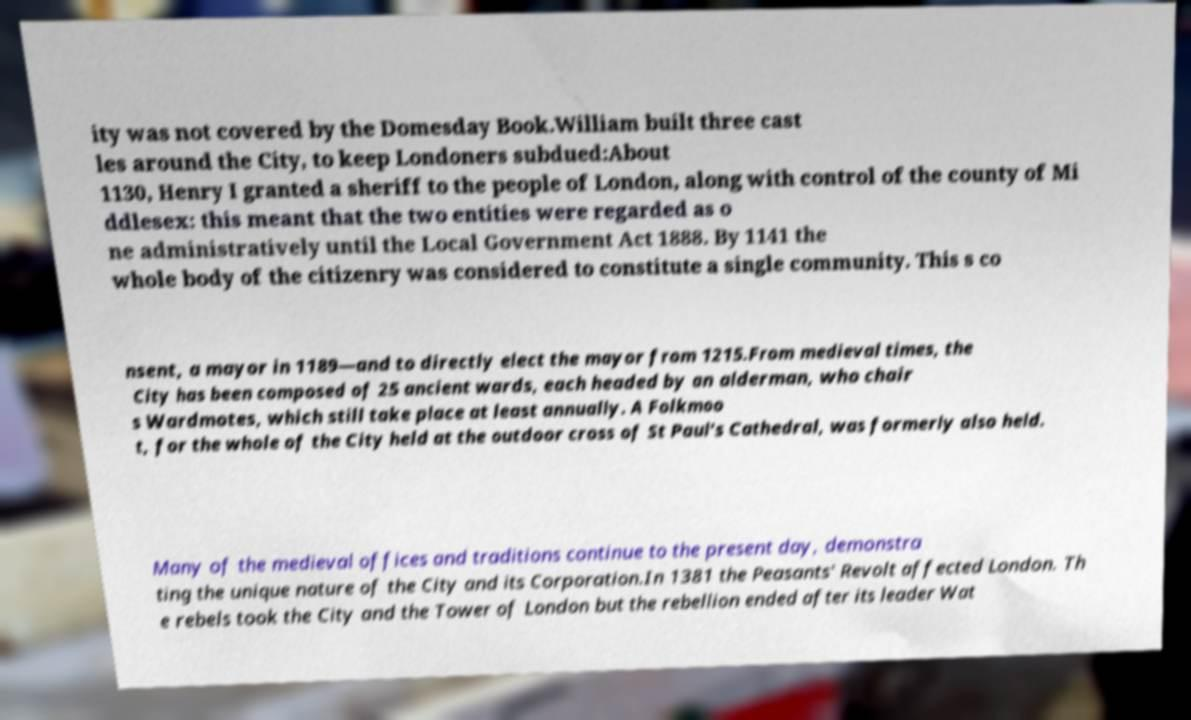There's text embedded in this image that I need extracted. Can you transcribe it verbatim? ity was not covered by the Domesday Book.William built three cast les around the City, to keep Londoners subdued:About 1130, Henry I granted a sheriff to the people of London, along with control of the county of Mi ddlesex: this meant that the two entities were regarded as o ne administratively until the Local Government Act 1888. By 1141 the whole body of the citizenry was considered to constitute a single community. This s co nsent, a mayor in 1189—and to directly elect the mayor from 1215.From medieval times, the City has been composed of 25 ancient wards, each headed by an alderman, who chair s Wardmotes, which still take place at least annually. A Folkmoo t, for the whole of the City held at the outdoor cross of St Paul's Cathedral, was formerly also held. Many of the medieval offices and traditions continue to the present day, demonstra ting the unique nature of the City and its Corporation.In 1381 the Peasants' Revolt affected London. Th e rebels took the City and the Tower of London but the rebellion ended after its leader Wat 